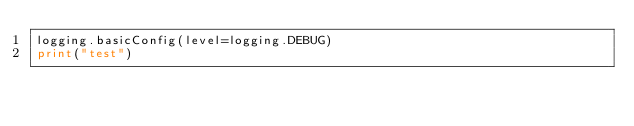<code> <loc_0><loc_0><loc_500><loc_500><_Python_>logging.basicConfig(level=logging.DEBUG)
print("test")</code> 